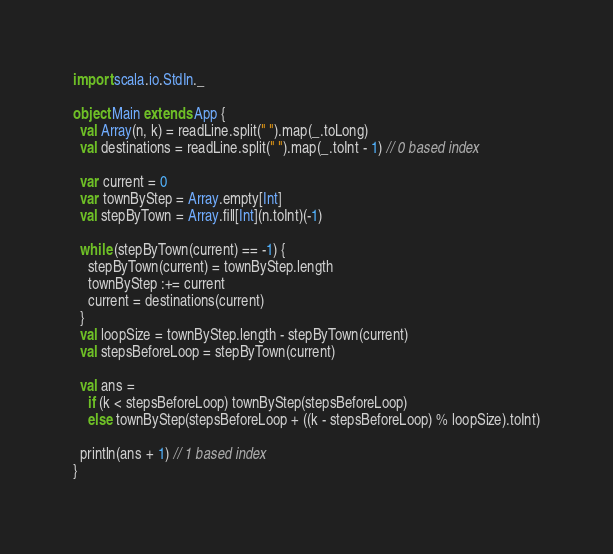Convert code to text. <code><loc_0><loc_0><loc_500><loc_500><_Scala_>import scala.io.StdIn._

object Main extends App {
  val Array(n, k) = readLine.split(" ").map(_.toLong)
  val destinations = readLine.split(" ").map(_.toInt - 1) // 0 based index

  var current = 0
  var townByStep = Array.empty[Int]
  val stepByTown = Array.fill[Int](n.toInt)(-1)

  while (stepByTown(current) == -1) {
    stepByTown(current) = townByStep.length
    townByStep :+= current
    current = destinations(current)
  }
  val loopSize = townByStep.length - stepByTown(current)
  val stepsBeforeLoop = stepByTown(current)

  val ans =
    if (k < stepsBeforeLoop) townByStep(stepsBeforeLoop)
    else townByStep(stepsBeforeLoop + ((k - stepsBeforeLoop) % loopSize).toInt)

  println(ans + 1) // 1 based index
}
</code> 